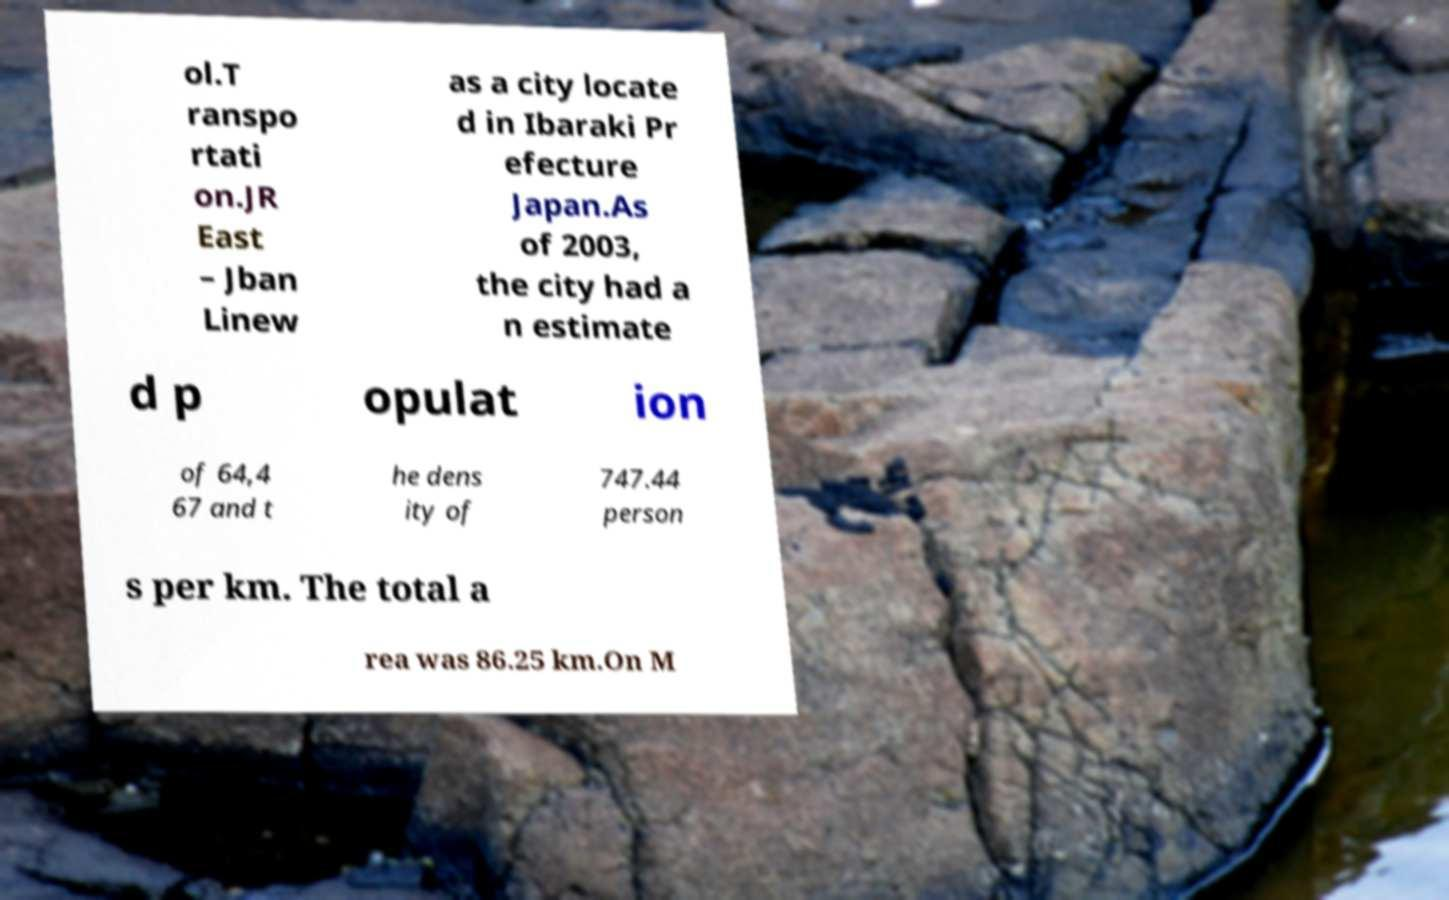Please identify and transcribe the text found in this image. ol.T ranspo rtati on.JR East – Jban Linew as a city locate d in Ibaraki Pr efecture Japan.As of 2003, the city had a n estimate d p opulat ion of 64,4 67 and t he dens ity of 747.44 person s per km. The total a rea was 86.25 km.On M 